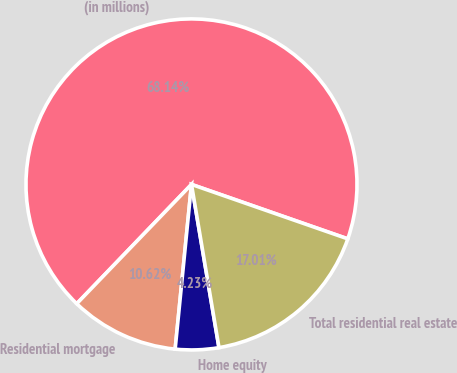Convert chart to OTSL. <chart><loc_0><loc_0><loc_500><loc_500><pie_chart><fcel>(in millions)<fcel>Residential mortgage<fcel>Home equity<fcel>Total residential real estate<nl><fcel>68.15%<fcel>10.62%<fcel>4.23%<fcel>17.01%<nl></chart> 